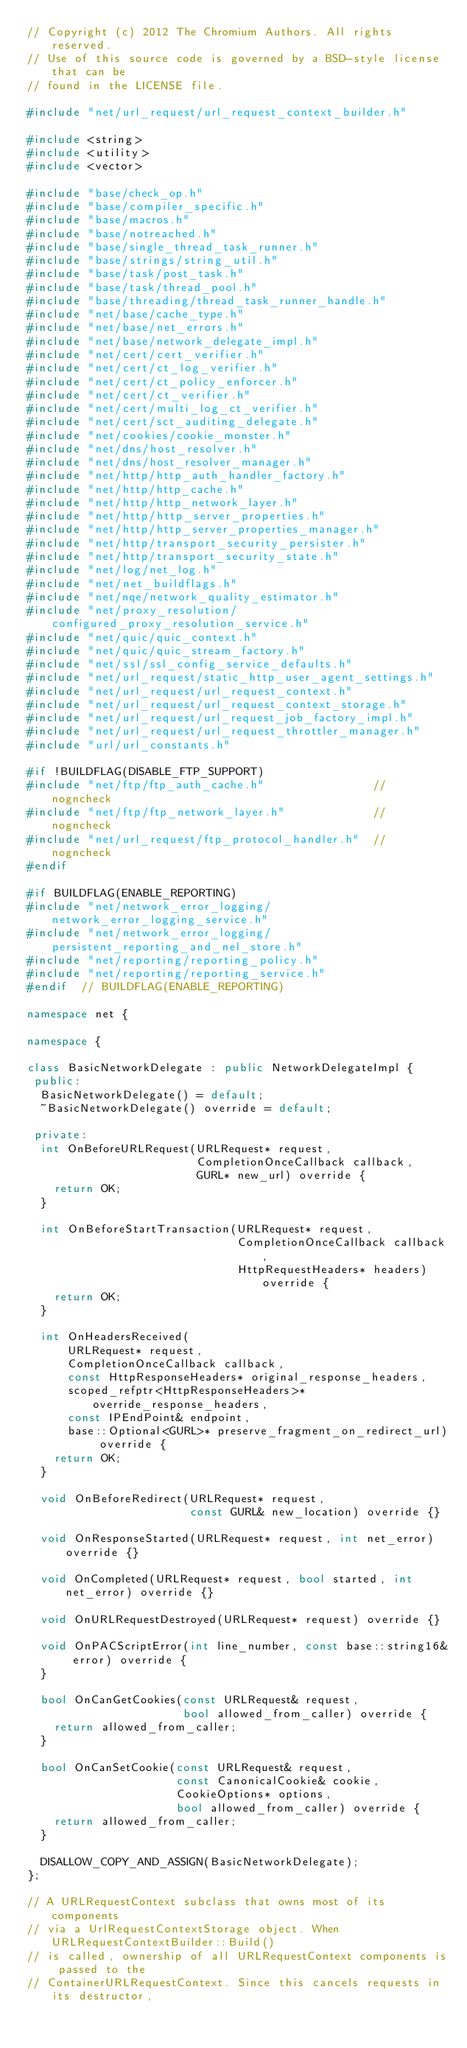<code> <loc_0><loc_0><loc_500><loc_500><_C++_>// Copyright (c) 2012 The Chromium Authors. All rights reserved.
// Use of this source code is governed by a BSD-style license that can be
// found in the LICENSE file.

#include "net/url_request/url_request_context_builder.h"

#include <string>
#include <utility>
#include <vector>

#include "base/check_op.h"
#include "base/compiler_specific.h"
#include "base/macros.h"
#include "base/notreached.h"
#include "base/single_thread_task_runner.h"
#include "base/strings/string_util.h"
#include "base/task/post_task.h"
#include "base/task/thread_pool.h"
#include "base/threading/thread_task_runner_handle.h"
#include "net/base/cache_type.h"
#include "net/base/net_errors.h"
#include "net/base/network_delegate_impl.h"
#include "net/cert/cert_verifier.h"
#include "net/cert/ct_log_verifier.h"
#include "net/cert/ct_policy_enforcer.h"
#include "net/cert/ct_verifier.h"
#include "net/cert/multi_log_ct_verifier.h"
#include "net/cert/sct_auditing_delegate.h"
#include "net/cookies/cookie_monster.h"
#include "net/dns/host_resolver.h"
#include "net/dns/host_resolver_manager.h"
#include "net/http/http_auth_handler_factory.h"
#include "net/http/http_cache.h"
#include "net/http/http_network_layer.h"
#include "net/http/http_server_properties.h"
#include "net/http/http_server_properties_manager.h"
#include "net/http/transport_security_persister.h"
#include "net/http/transport_security_state.h"
#include "net/log/net_log.h"
#include "net/net_buildflags.h"
#include "net/nqe/network_quality_estimator.h"
#include "net/proxy_resolution/configured_proxy_resolution_service.h"
#include "net/quic/quic_context.h"
#include "net/quic/quic_stream_factory.h"
#include "net/ssl/ssl_config_service_defaults.h"
#include "net/url_request/static_http_user_agent_settings.h"
#include "net/url_request/url_request_context.h"
#include "net/url_request/url_request_context_storage.h"
#include "net/url_request/url_request_job_factory_impl.h"
#include "net/url_request/url_request_throttler_manager.h"
#include "url/url_constants.h"

#if !BUILDFLAG(DISABLE_FTP_SUPPORT)
#include "net/ftp/ftp_auth_cache.h"                // nogncheck
#include "net/ftp/ftp_network_layer.h"             // nogncheck
#include "net/url_request/ftp_protocol_handler.h"  // nogncheck
#endif

#if BUILDFLAG(ENABLE_REPORTING)
#include "net/network_error_logging/network_error_logging_service.h"
#include "net/network_error_logging/persistent_reporting_and_nel_store.h"
#include "net/reporting/reporting_policy.h"
#include "net/reporting/reporting_service.h"
#endif  // BUILDFLAG(ENABLE_REPORTING)

namespace net {

namespace {

class BasicNetworkDelegate : public NetworkDelegateImpl {
 public:
  BasicNetworkDelegate() = default;
  ~BasicNetworkDelegate() override = default;

 private:
  int OnBeforeURLRequest(URLRequest* request,
                         CompletionOnceCallback callback,
                         GURL* new_url) override {
    return OK;
  }

  int OnBeforeStartTransaction(URLRequest* request,
                               CompletionOnceCallback callback,
                               HttpRequestHeaders* headers) override {
    return OK;
  }

  int OnHeadersReceived(
      URLRequest* request,
      CompletionOnceCallback callback,
      const HttpResponseHeaders* original_response_headers,
      scoped_refptr<HttpResponseHeaders>* override_response_headers,
      const IPEndPoint& endpoint,
      base::Optional<GURL>* preserve_fragment_on_redirect_url) override {
    return OK;
  }

  void OnBeforeRedirect(URLRequest* request,
                        const GURL& new_location) override {}

  void OnResponseStarted(URLRequest* request, int net_error) override {}

  void OnCompleted(URLRequest* request, bool started, int net_error) override {}

  void OnURLRequestDestroyed(URLRequest* request) override {}

  void OnPACScriptError(int line_number, const base::string16& error) override {
  }

  bool OnCanGetCookies(const URLRequest& request,
                       bool allowed_from_caller) override {
    return allowed_from_caller;
  }

  bool OnCanSetCookie(const URLRequest& request,
                      const CanonicalCookie& cookie,
                      CookieOptions* options,
                      bool allowed_from_caller) override {
    return allowed_from_caller;
  }

  DISALLOW_COPY_AND_ASSIGN(BasicNetworkDelegate);
};

// A URLRequestContext subclass that owns most of its components
// via a UrlRequestContextStorage object. When URLRequestContextBuilder::Build()
// is called, ownership of all URLRequestContext components is passed to the
// ContainerURLRequestContext. Since this cancels requests in its destructor,</code> 